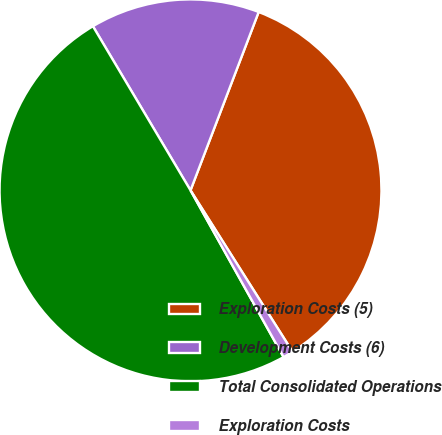Convert chart to OTSL. <chart><loc_0><loc_0><loc_500><loc_500><pie_chart><fcel>Exploration Costs (5)<fcel>Development Costs (6)<fcel>Total Consolidated Operations<fcel>Exploration Costs<nl><fcel>35.22%<fcel>14.35%<fcel>49.57%<fcel>0.87%<nl></chart> 